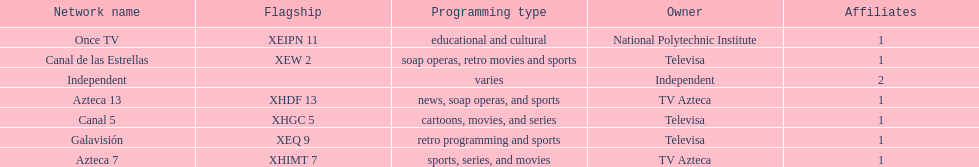How many affiliates does galavision have? 1. Write the full table. {'header': ['Network name', 'Flagship', 'Programming type', 'Owner', 'Affiliates'], 'rows': [['Once TV', 'XEIPN 11', 'educational and cultural', 'National Polytechnic Institute', '1'], ['Canal de las Estrellas', 'XEW 2', 'soap operas, retro movies and sports', 'Televisa', '1'], ['Independent', '', 'varies', 'Independent', '2'], ['Azteca 13', 'XHDF 13', 'news, soap operas, and sports', 'TV Azteca', '1'], ['Canal 5', 'XHGC 5', 'cartoons, movies, and series', 'Televisa', '1'], ['Galavisión', 'XEQ 9', 'retro programming and sports', 'Televisa', '1'], ['Azteca 7', 'XHIMT 7', 'sports, series, and movies', 'TV Azteca', '1']]} 